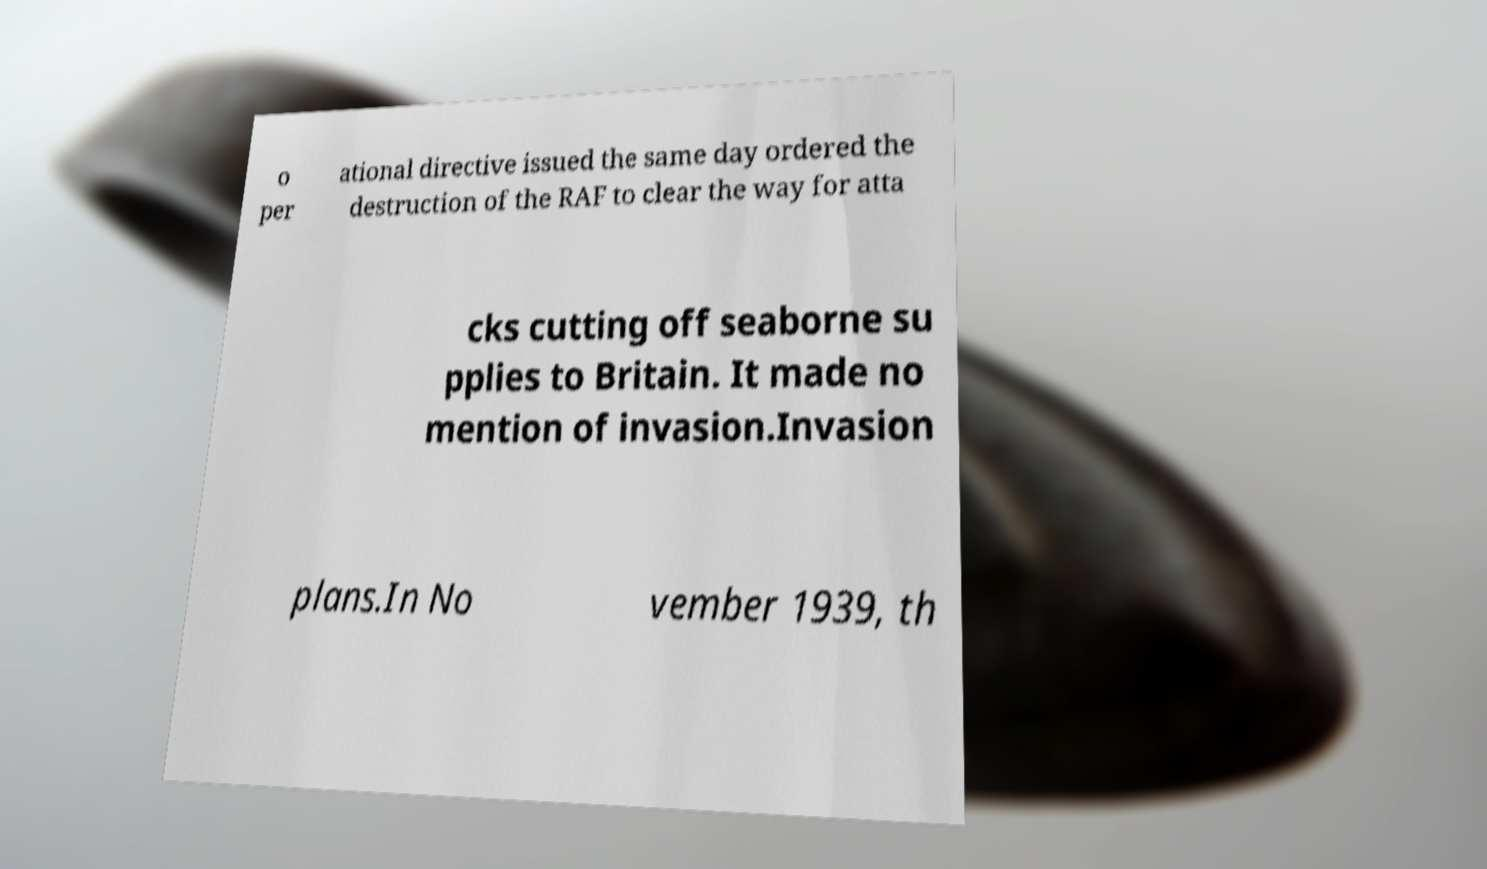What messages or text are displayed in this image? I need them in a readable, typed format. o per ational directive issued the same day ordered the destruction of the RAF to clear the way for atta cks cutting off seaborne su pplies to Britain. It made no mention of invasion.Invasion plans.In No vember 1939, th 